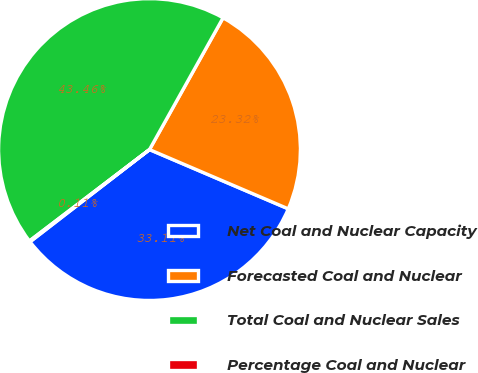Convert chart. <chart><loc_0><loc_0><loc_500><loc_500><pie_chart><fcel>Net Coal and Nuclear Capacity<fcel>Forecasted Coal and Nuclear<fcel>Total Coal and Nuclear Sales<fcel>Percentage Coal and Nuclear<nl><fcel>33.11%<fcel>23.32%<fcel>43.46%<fcel>0.11%<nl></chart> 